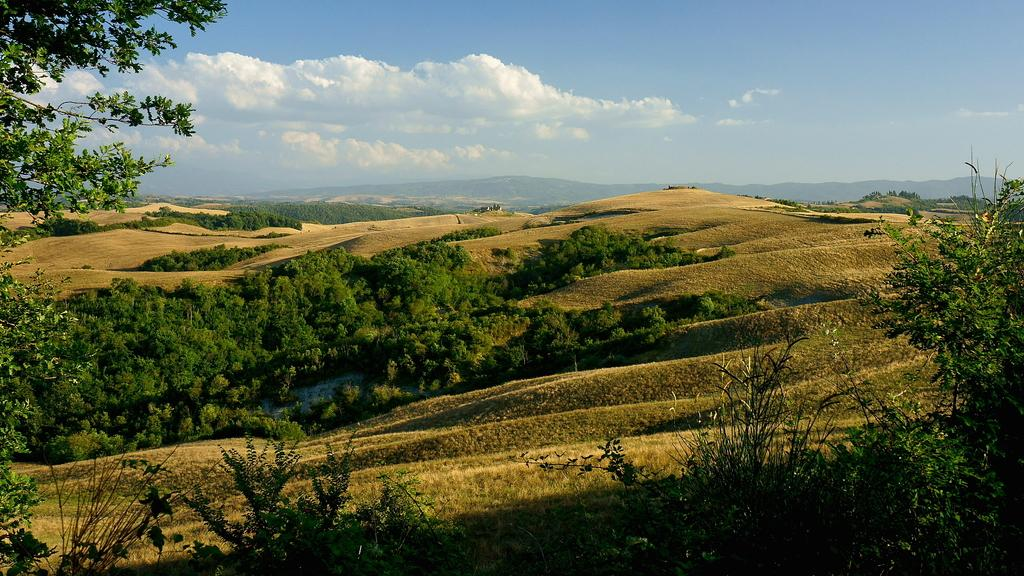What type of vegetation is in the foreground of the image? There is greenery in the foreground of the image, which appears to be grassland. What can be seen in the background of the image? Mountains and the sky are visible in the background of the image. What type of humor can be seen in the image? There is no humor present in the image; it features a landscape with grassland, mountains, and the sky. 